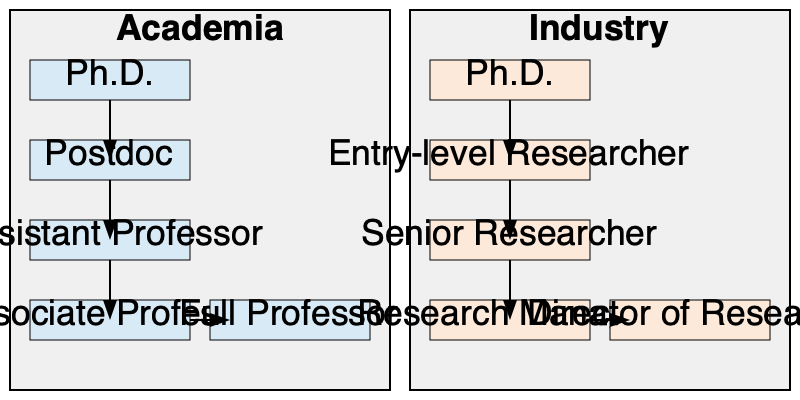Based on the parallel flowcharts comparing career progression in academia and industry, what is the key difference in the number of major career stages between the two paths after obtaining a Ph.D.? To answer this question, we need to analyze and compare the career progression paths shown in the flowcharts for both academia and industry:

1. Academia path:
   a. Ph.D.
   b. Postdoc
   c. Assistant Professor
   d. Associate Professor
   e. Full Professor

2. Industry path:
   a. Ph.D.
   b. Entry-level Researcher
   c. Senior Researcher
   d. Research Manager
   e. Director of Research

3. Counting the major career stages:
   - Academia: 5 stages (including Ph.D.)
   - Industry: 5 stages (including Ph.D.)

4. Comparing the number of stages:
   - Both paths have the same number of major career stages (5)
   - The key difference is not in the number of stages, but in the nature of the positions

5. Identifying the key difference:
   - In academia, there is a distinct "Postdoc" stage between Ph.D. and Assistant Professor
   - In industry, there is no equivalent to the "Postdoc" stage; instead, Ph.D. graduates typically move directly into Entry-level Researcher positions

Therefore, the key difference in the number of major career stages between the two paths after obtaining a Ph.D. is that academia has one additional stage (Postdoc) before entering a faculty position, while industry does not have this intermediate stage.
Answer: Academia has one additional stage (Postdoc) after Ph.D. before entering a faculty position, while industry does not. 